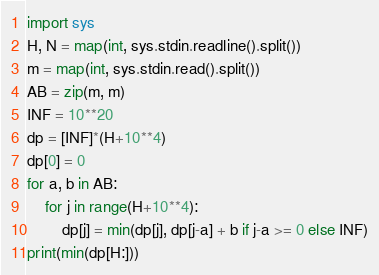<code> <loc_0><loc_0><loc_500><loc_500><_Python_>import sys
H, N = map(int, sys.stdin.readline().split())
m = map(int, sys.stdin.read().split())
AB = zip(m, m)
INF = 10**20
dp = [INF]*(H+10**4)
dp[0] = 0
for a, b in AB:
    for j in range(H+10**4):
        dp[j] = min(dp[j], dp[j-a] + b if j-a >= 0 else INF)
print(min(dp[H:]))
</code> 